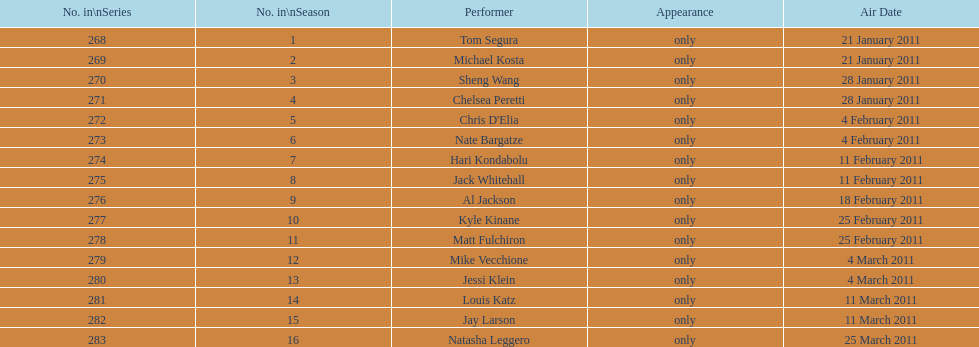Which month had the most performers? February. 